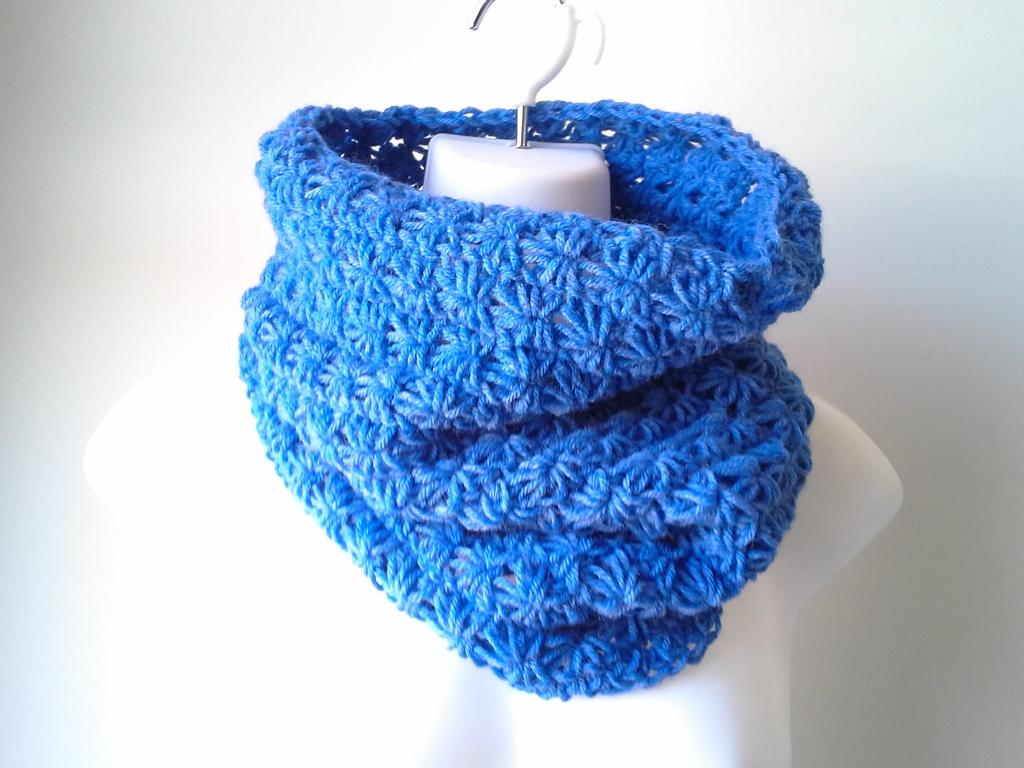What type of material is the cloth made of in the image? The cloth in the image is made up of wool. What color is the woolen cloth? The woolen cloth is in blue color. What can be seen hanging on the wall in the image? There is a hanger in white color in the image. What is visible in the background of the image? There is a wall in the background of the image. Can you see the coach and moon in the image? No, there is no coach or moon present in the image. 